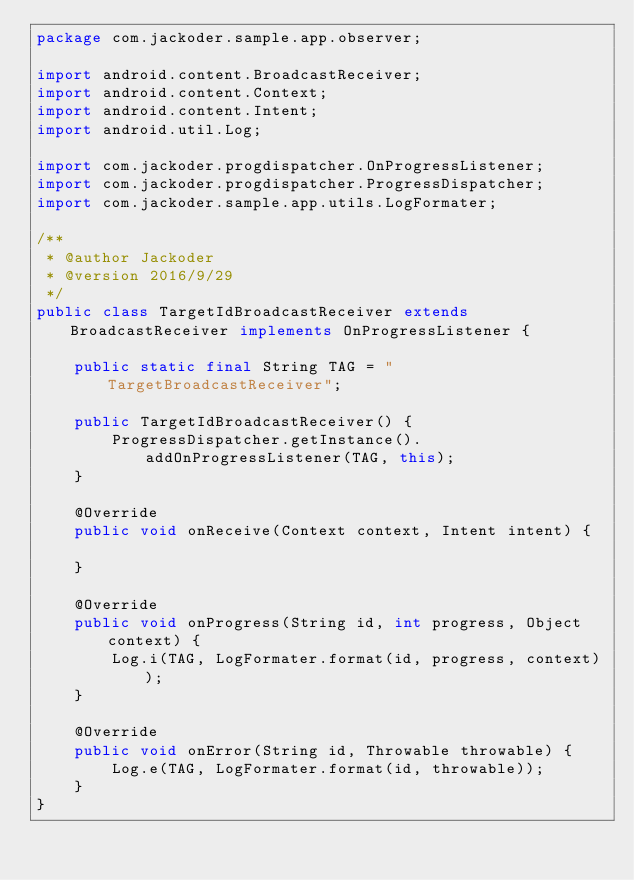Convert code to text. <code><loc_0><loc_0><loc_500><loc_500><_Java_>package com.jackoder.sample.app.observer;

import android.content.BroadcastReceiver;
import android.content.Context;
import android.content.Intent;
import android.util.Log;

import com.jackoder.progdispatcher.OnProgressListener;
import com.jackoder.progdispatcher.ProgressDispatcher;
import com.jackoder.sample.app.utils.LogFormater;

/**
 * @author Jackoder
 * @version 2016/9/29
 */
public class TargetIdBroadcastReceiver extends BroadcastReceiver implements OnProgressListener {

    public static final String TAG = "TargetBroadcastReceiver";

    public TargetIdBroadcastReceiver() {
        ProgressDispatcher.getInstance().addOnProgressListener(TAG, this);
    }

    @Override
    public void onReceive(Context context, Intent intent) {

    }

    @Override
    public void onProgress(String id, int progress, Object context) {
        Log.i(TAG, LogFormater.format(id, progress, context));
    }

    @Override
    public void onError(String id, Throwable throwable) {
        Log.e(TAG, LogFormater.format(id, throwable));
    }
}
</code> 